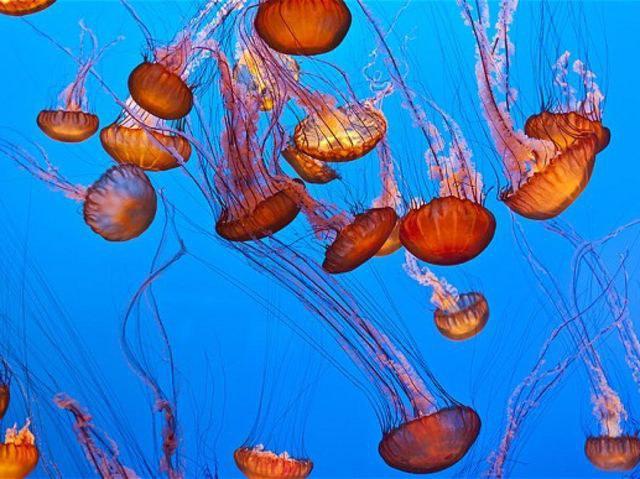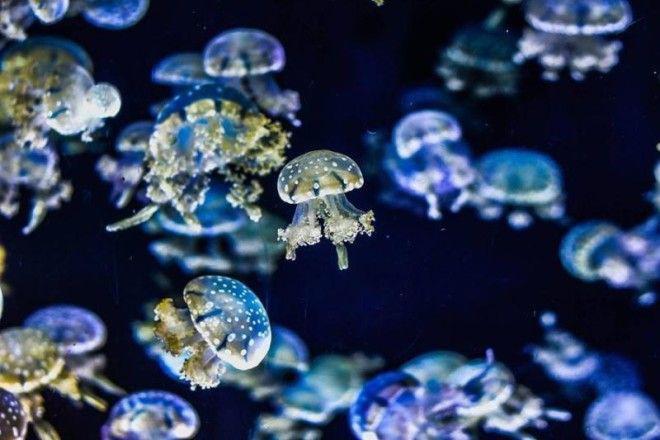The first image is the image on the left, the second image is the image on the right. Examine the images to the left and right. Is the description "The pink jellyfish in the image on the left is against a black background." accurate? Answer yes or no. No. 